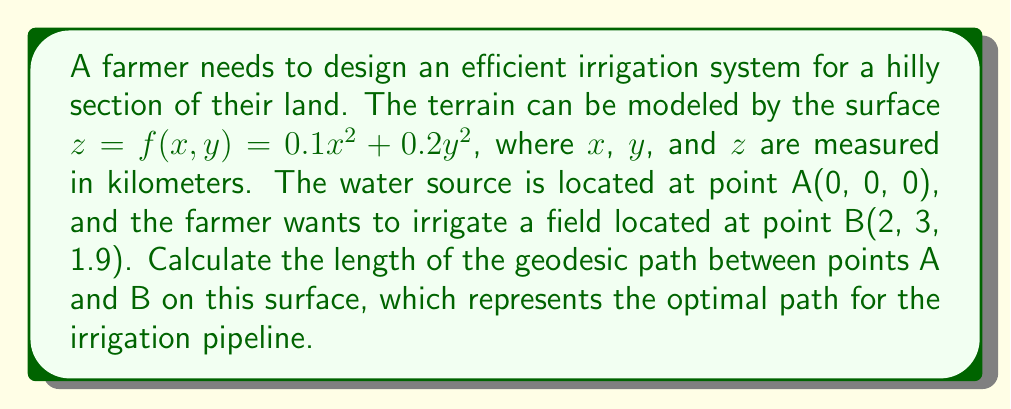Help me with this question. To solve this problem, we need to follow these steps:

1) First, we need to calculate the metric tensor for the surface. The metric tensor is given by:

   $$g_{ij} = \begin{pmatrix}
   1 + (\frac{\partial f}{\partial x})^2 & \frac{\partial f}{\partial x}\frac{\partial f}{\partial y} \\
   \frac{\partial f}{\partial x}\frac{\partial f}{\partial y} & 1 + (\frac{\partial f}{\partial y})^2
   \end{pmatrix}$$

2) We calculate the partial derivatives:
   
   $\frac{\partial f}{\partial x} = 0.2x$
   $\frac{\partial f}{\partial y} = 0.4y$

3) Substituting these into the metric tensor:

   $$g_{ij} = \begin{pmatrix}
   1 + 0.04x^2 & 0.08xy \\
   0.08xy & 1 + 0.16y^2
   \end{pmatrix}$$

4) The geodesic equation on a surface is given by:

   $$\frac{d^2x^i}{dt^2} + \Gamma^i_{jk}\frac{dx^j}{dt}\frac{dx^k}{dt} = 0$$

   where $\Gamma^i_{jk}$ are the Christoffel symbols.

5) Solving this differential equation analytically is complex. In practice, numerical methods are often used. For this problem, we'll use an approximation method.

6) We can approximate the length of the geodesic using the straight-line distance in the embedded space (R³). While this isn't exactly the geodesic, it provides a reasonable estimate for surfaces with mild curvature.

7) The straight-line distance in R³ is given by:

   $$d = \sqrt{(x_2-x_1)^2 + (y_2-y_1)^2 + (z_2-z_1)^2}$$

8) Substituting the coordinates of points A and B:

   $$d = \sqrt{(2-0)^2 + (3-0)^2 + (1.9-0)^2}$$

9) Calculating:

   $$d = \sqrt{4 + 9 + 3.61} = \sqrt{16.61} \approx 4.075$$

Therefore, the approximate length of the geodesic path is about 4.075 kilometers.
Answer: The approximate length of the optimal path for the irrigation pipeline (geodesic) between points A(0, 0, 0) and B(2, 3, 1.9) is 4.075 kilometers. 